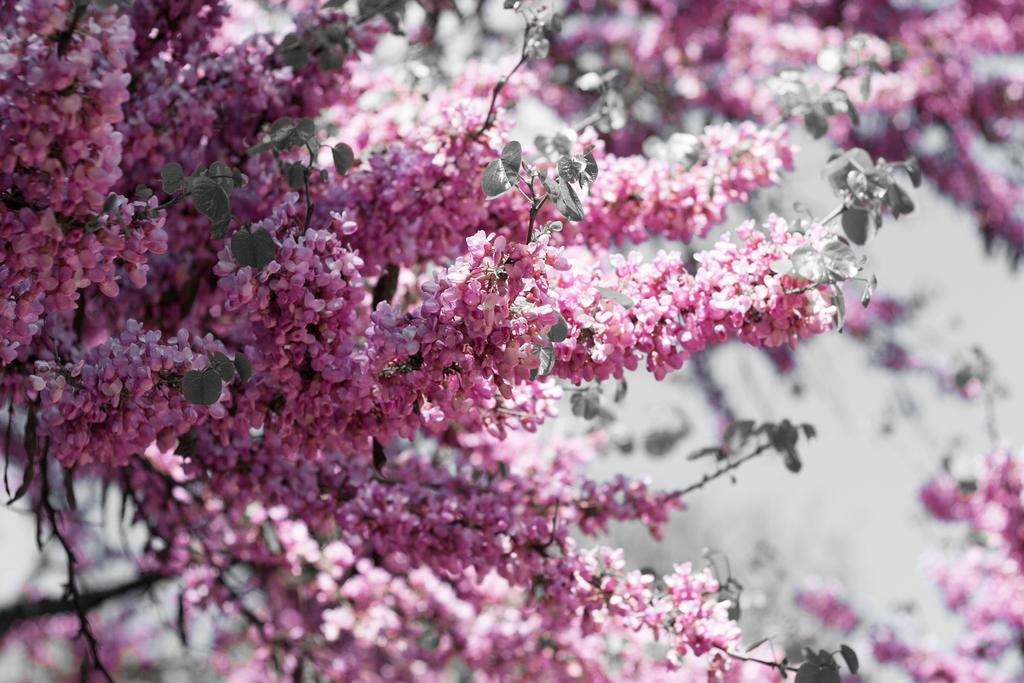What is present in the image? There is a tree in the image. What can be observed about the tree? The tree has flowers on its branches. What type of meat is hanging from the tree in the image? There is no meat present in the image; it only features a tree with flowers on its branches. 